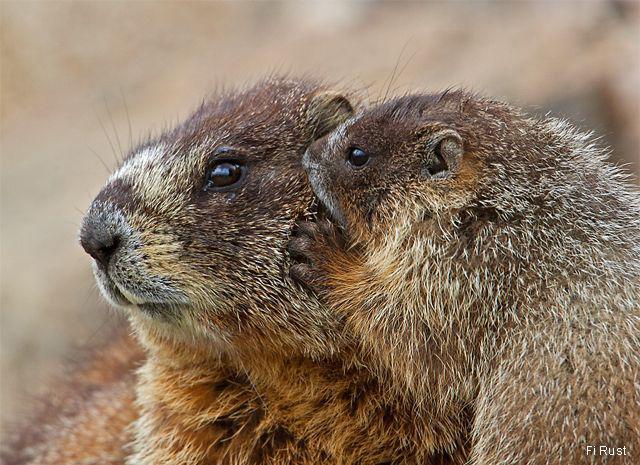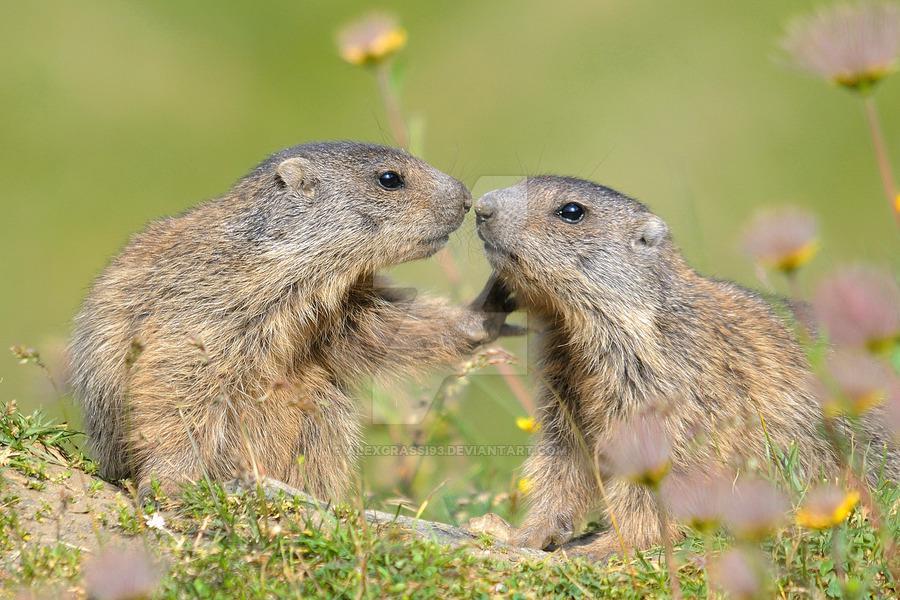The first image is the image on the left, the second image is the image on the right. Analyze the images presented: Is the assertion "Each image contains exactly one pair of marmots, and at least one pair is face-to-face." valid? Answer yes or no. Yes. The first image is the image on the left, the second image is the image on the right. For the images shown, is this caption "Two rodents interact together outside in each of the images." true? Answer yes or no. Yes. 